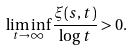<formula> <loc_0><loc_0><loc_500><loc_500>\liminf _ { t \to \infty } \frac { \xi ( s , t ) } { \log t } & > 0 .</formula> 